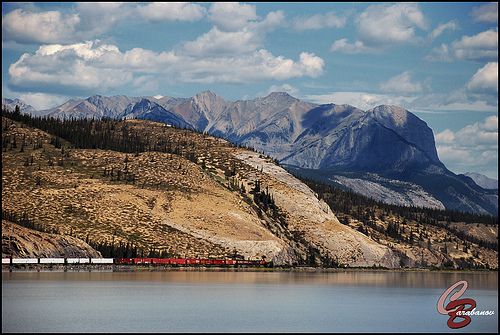<image>
Is the mountain on the hill? No. The mountain is not positioned on the hill. They may be near each other, but the mountain is not supported by or resting on top of the hill. 